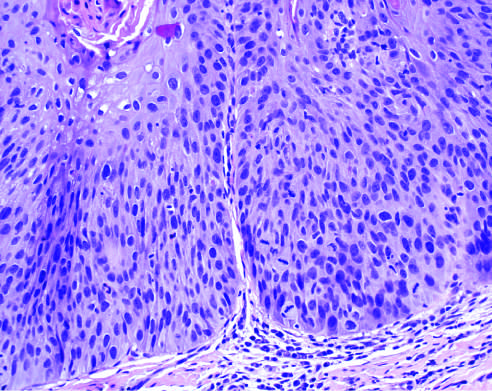what is characterized by nuclear and cellular pleomorphism and loss of normal maturation?
Answer the question using a single word or phrase. Dysplasia 